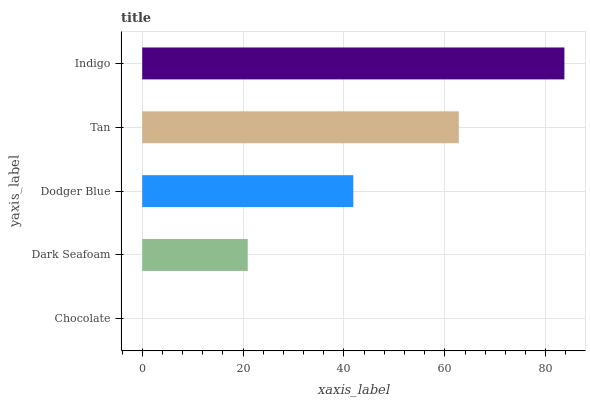Is Chocolate the minimum?
Answer yes or no. Yes. Is Indigo the maximum?
Answer yes or no. Yes. Is Dark Seafoam the minimum?
Answer yes or no. No. Is Dark Seafoam the maximum?
Answer yes or no. No. Is Dark Seafoam greater than Chocolate?
Answer yes or no. Yes. Is Chocolate less than Dark Seafoam?
Answer yes or no. Yes. Is Chocolate greater than Dark Seafoam?
Answer yes or no. No. Is Dark Seafoam less than Chocolate?
Answer yes or no. No. Is Dodger Blue the high median?
Answer yes or no. Yes. Is Dodger Blue the low median?
Answer yes or no. Yes. Is Tan the high median?
Answer yes or no. No. Is Tan the low median?
Answer yes or no. No. 